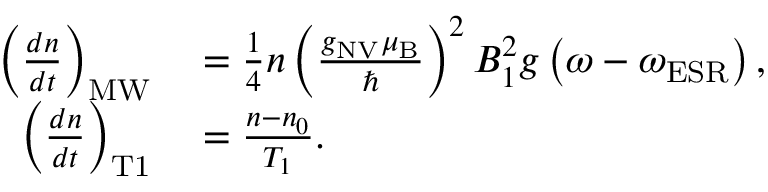<formula> <loc_0><loc_0><loc_500><loc_500>\begin{array} { r l } { \left ( \frac { d n } { d t } \right ) _ { M W } } & = \frac { 1 } { 4 } n \left ( \frac { g _ { N V } \mu _ { B } } { } \right ) ^ { 2 } B _ { 1 } ^ { 2 } g \left ( \omega - \omega _ { E S R } \right ) , } \\ { \left ( \frac { d n } { d t } \right ) _ { T 1 } } & = \frac { n - n _ { 0 } } { T _ { 1 } } . } \end{array}</formula> 